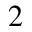<formula> <loc_0><loc_0><loc_500><loc_500>_ { 2 }</formula> 